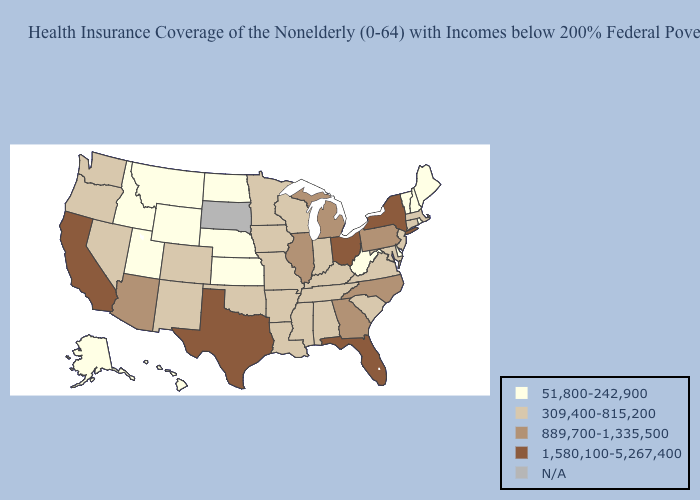Among the states that border Nebraska , does Wyoming have the highest value?
Keep it brief. No. What is the lowest value in the USA?
Be succinct. 51,800-242,900. What is the value of Colorado?
Keep it brief. 309,400-815,200. What is the lowest value in states that border Alabama?
Write a very short answer. 309,400-815,200. Name the states that have a value in the range N/A?
Keep it brief. South Dakota. What is the highest value in the USA?
Keep it brief. 1,580,100-5,267,400. What is the highest value in the USA?
Concise answer only. 1,580,100-5,267,400. Which states have the lowest value in the USA?
Concise answer only. Alaska, Delaware, Hawaii, Idaho, Kansas, Maine, Montana, Nebraska, New Hampshire, North Dakota, Rhode Island, Utah, Vermont, West Virginia, Wyoming. Name the states that have a value in the range 51,800-242,900?
Be succinct. Alaska, Delaware, Hawaii, Idaho, Kansas, Maine, Montana, Nebraska, New Hampshire, North Dakota, Rhode Island, Utah, Vermont, West Virginia, Wyoming. What is the value of Maine?
Write a very short answer. 51,800-242,900. Name the states that have a value in the range 309,400-815,200?
Concise answer only. Alabama, Arkansas, Colorado, Connecticut, Indiana, Iowa, Kentucky, Louisiana, Maryland, Massachusetts, Minnesota, Mississippi, Missouri, Nevada, New Jersey, New Mexico, Oklahoma, Oregon, South Carolina, Tennessee, Virginia, Washington, Wisconsin. Does Indiana have the lowest value in the USA?
Give a very brief answer. No. Does Iowa have the lowest value in the MidWest?
Answer briefly. No. What is the highest value in states that border Pennsylvania?
Write a very short answer. 1,580,100-5,267,400. Among the states that border Indiana , does Kentucky have the lowest value?
Short answer required. Yes. 